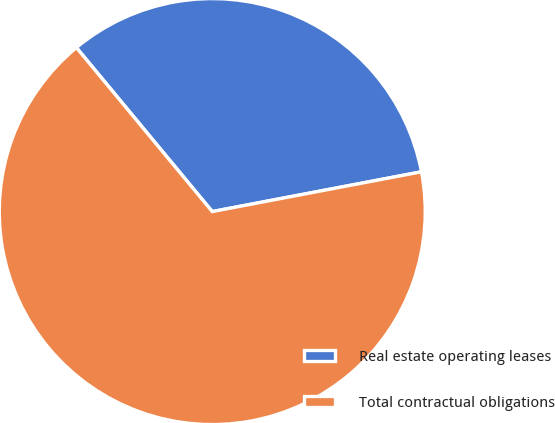<chart> <loc_0><loc_0><loc_500><loc_500><pie_chart><fcel>Real estate operating leases<fcel>Total contractual obligations<nl><fcel>33.02%<fcel>66.98%<nl></chart> 